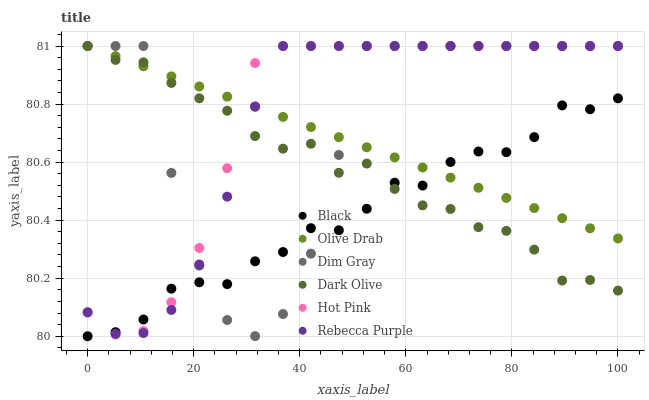Does Black have the minimum area under the curve?
Answer yes or no. Yes. Does Hot Pink have the maximum area under the curve?
Answer yes or no. Yes. Does Dark Olive have the minimum area under the curve?
Answer yes or no. No. Does Dark Olive have the maximum area under the curve?
Answer yes or no. No. Is Olive Drab the smoothest?
Answer yes or no. Yes. Is Dim Gray the roughest?
Answer yes or no. Yes. Is Dark Olive the smoothest?
Answer yes or no. No. Is Dark Olive the roughest?
Answer yes or no. No. Does Black have the lowest value?
Answer yes or no. Yes. Does Dark Olive have the lowest value?
Answer yes or no. No. Does Olive Drab have the highest value?
Answer yes or no. Yes. Does Black have the highest value?
Answer yes or no. No. Does Dim Gray intersect Rebecca Purple?
Answer yes or no. Yes. Is Dim Gray less than Rebecca Purple?
Answer yes or no. No. Is Dim Gray greater than Rebecca Purple?
Answer yes or no. No. 